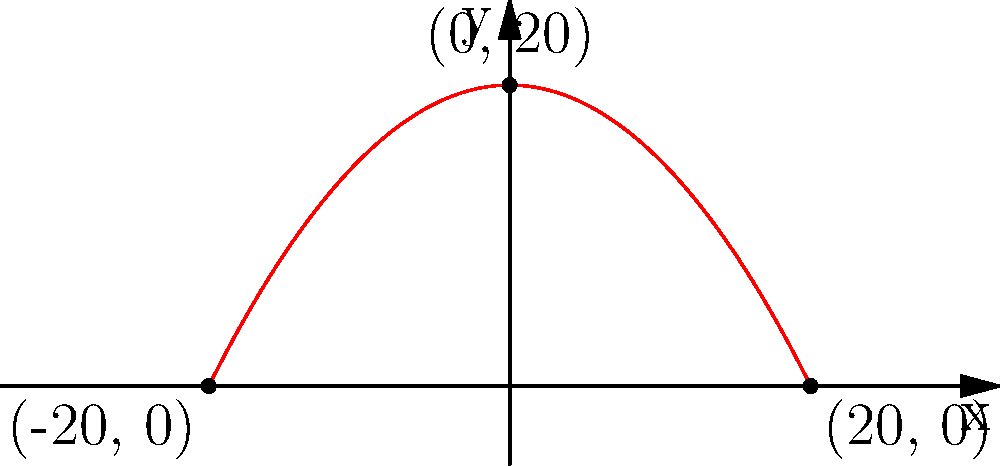An ancient Egyptian obelisk has an arc that can be modeled by a parabola. The apex of the obelisk reaches a height of 20 meters, and the base spans 40 meters (-20 to 20 on the x-axis). Using this information, determine the equation of the parabola that represents the arc of the obelisk. To find the equation of the parabola, we'll use the general form $f(x) = a(x-h)^2 + k$, where $(h,k)$ is the vertex.

1. The vertex is at (0, 20), so $h=0$ and $k=20$.

2. We can simplify the equation to $f(x) = ax^2 + 20$.

3. We know that the parabola passes through the points (-20, 0) and (20, 0).

4. Let's use (20, 0):
   $0 = a(20)^2 + 20$
   $0 = 400a + 20$
   $-20 = 400a$
   $a = -\frac{1}{20} = -0.05$

5. Therefore, the equation is $f(x) = -0.05x^2 + 20$.

6. We can verify this works for (-20, 0):
   $f(-20) = -0.05(-20)^2 + 20 = -0.05(400) + 20 = -20 + 20 = 0$

Thus, the equation $f(x) = -0.05x^2 + 20$ accurately models the arc of the obelisk.
Answer: $f(x) = -0.05x^2 + 20$ 